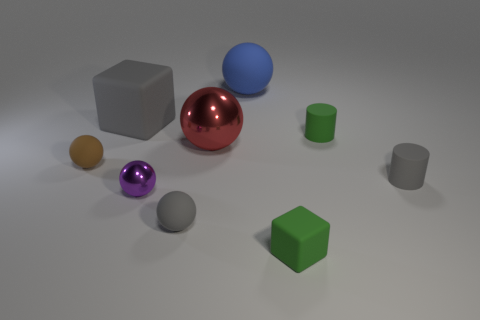There is a rubber object that is to the right of the big blue rubber sphere and behind the red ball; what is its shape? cylinder 